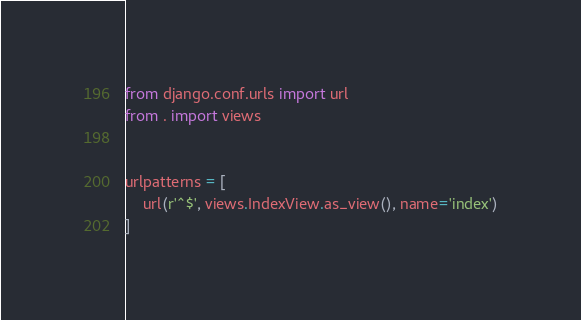Convert code to text. <code><loc_0><loc_0><loc_500><loc_500><_Python_>from django.conf.urls import url
from . import views


urlpatterns = [
    url(r'^$', views.IndexView.as_view(), name='index')
]</code> 